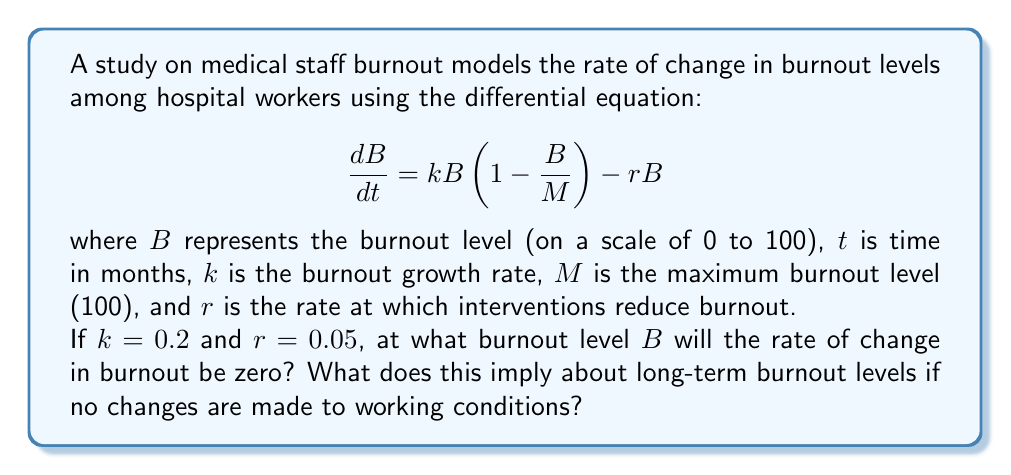Show me your answer to this math problem. To solve this problem, we need to find the equilibrium point of the differential equation, which occurs when $\frac{dB}{dt} = 0$. Let's approach this step-by-step:

1) Set the differential equation equal to zero:

   $$\frac{dB}{dt} = kB(1-\frac{B}{M}) - rB = 0$$

2) Substitute the given values: $k = 0.2$, $r = 0.05$, and $M = 100$:

   $$0.2B(1-\frac{B}{100}) - 0.05B = 0$$

3) Factor out $B$:

   $$B(0.2(1-\frac{B}{100}) - 0.05) = 0$$

4) This equation is satisfied when either $B = 0$ or the term in parentheses equals zero. Let's solve the latter:

   $$0.2(1-\frac{B}{100}) - 0.05 = 0$$

5) Multiply both sides by 100:

   $$20(1-\frac{B}{100}) - 5 = 0$$

6) Distribute:

   $$20 - \frac{20B}{100} - 5 = 0$$

7) Simplify:

   $$15 - 0.2B = 0$$

8) Add 0.2B to both sides:

   $$15 = 0.2B$$

9) Divide both sides by 0.2:

   $$B = 75$$

Therefore, the rate of change in burnout will be zero when $B = 75$. This implies that if no changes are made to working conditions, the long-term burnout level will stabilize at 75 out of 100, which is a significantly high level of burnout.
Answer: The burnout level $B$ at which the rate of change will be zero is 75. This implies that without intervention, long-term burnout levels will stabilize at a high level of 75 out of 100. 